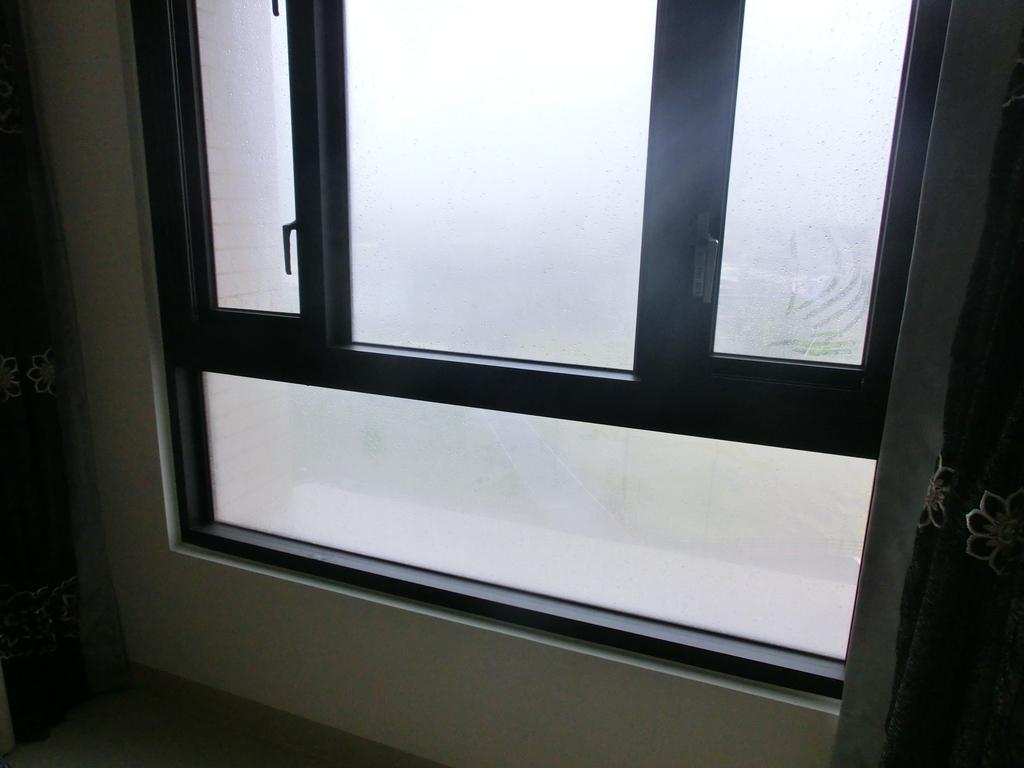What is located in the center of the image? There is a window in the center of the image. What type of window treatment is present on the right side of the image? There are curtains on the right side of the image. What type of window treatment is present on the left side of the image? There are curtains on the left side of the image. What can be seen behind the window? There is a wall visible in the image. What is at the bottom of the image? There is a floor at the bottom of the image. What verse is being recited by the zephyr in the image? There is no zephyr or verse present in the image. 